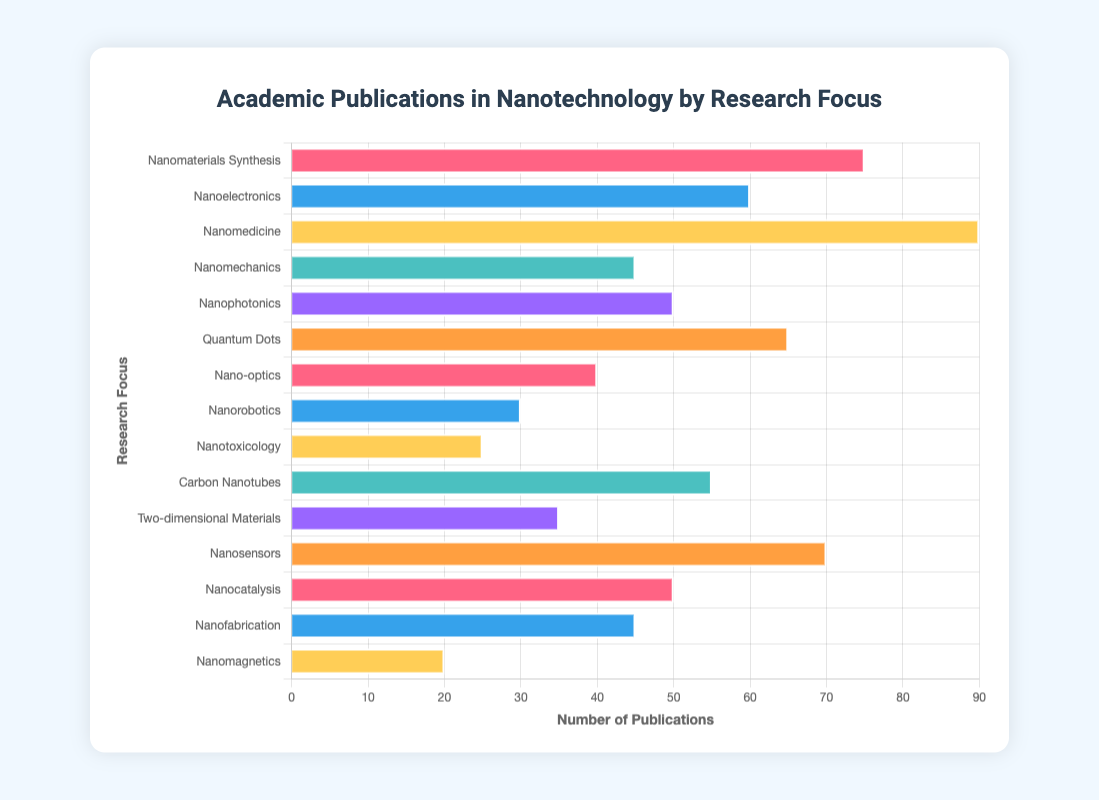Which research focus has the highest number of academic publications? By examining the lengths of the bars, the longest bar corresponds to Nanomedicine, indicating it has the highest number of publications.
Answer: Nanomedicine Which research focuses have fewer publications than Nanoelectronics? First, locate Nanoelectronics which has 60 publications. Next, identify the bars with lengths shorter than Nanoelectronics: Nanomechanics (45), Nanophotonics (50), Nano-optics (40), Nanorobotics (30), Nanotoxicology (25), Two-dimensional Materials (35), Nanofabrication (45), and Nanomagnetics (20).
Answer: Nanomechanics, Nanophotonics, Nano-optics, Nanorobotics, Nanotoxicology, Two-dimensional Materials, Nanofabrication, Nanomagnetics What is the total number of publications for Carbon Nanotubes and Quantum Dots? Find the length of the bars for Carbon Nanotubes (55) and Quantum Dots (65), then sum them up: 55 + 65 = 120.
Answer: 120 Which research focus has the least number of academic publications, and how many are there? The shortest bar indicates the least number of publications. The shortest bar corresponds to Nanomagnetics with 20 publications.
Answer: Nanomagnetics, 20 How many more publications does Nanomedicine have compared to Nanomechanics? Identify the publications for Nanomedicine (90) and Nanomechanics (45), then subtract the latter from the former: 90 - 45 = 45.
Answer: 45 Which research focuses have an equal number of publications? By observing the bar lengths, Nanophotonics and Nanocatalysis both have bars of the same length, each corresponding to 50 publications. Similarly, Nanomechanics and Nanofabrication each have 45 publications.
Answer: Nanophotonics & Nanocatalysis, Nanomechanics & Nanofabrication What is the average number of publications across all research focuses represented in the chart? Add the number of publications for each research focus (75 + 60 + 90 + 45 + 50 + 65 + 40 + 30 + 25 + 55 + 35 + 70 + 50 + 45 + 20 = 755). Divide the total by the number of research focuses (15): 755 / 15 = 50.3.
Answer: 50.3 Which research focus areas have more than 50 but fewer than 70 publications? Identify the bars with values within this range: Nanoelectronics (60), Quantum Dots (65), and Nanosensors (70). However, since 70 is not fewer, only Nanoelectronics and Quantum Dots remain.
Answer: Nanoelectronics, Quantum Dots 